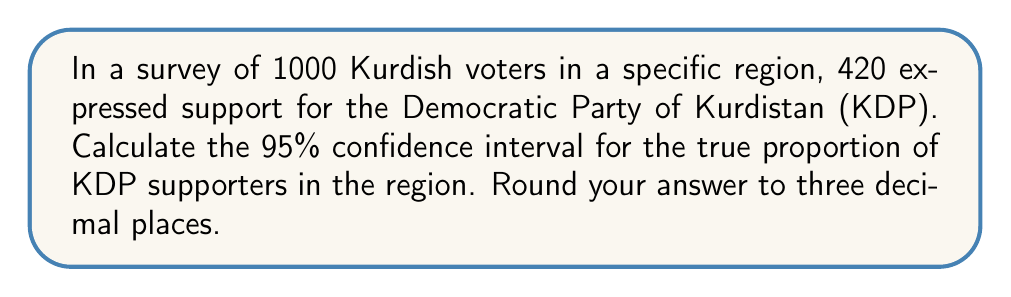Can you solve this math problem? To calculate the confidence interval, we'll use the formula for the margin of error in a proportion:

1. Calculate the sample proportion:
   $\hat{p} = \frac{420}{1000} = 0.42$

2. Calculate the standard error:
   $SE = \sqrt{\frac{\hat{p}(1-\hat{p})}{n}} = \sqrt{\frac{0.42(1-0.42)}{1000}} = 0.0156$

3. For a 95% confidence interval, we use a z-score of 1.96.

4. Calculate the margin of error:
   $ME = 1.96 \times SE = 1.96 \times 0.0156 = 0.0306$

5. Calculate the confidence interval:
   Lower bound: $0.42 - 0.0306 = 0.3894$
   Upper bound: $0.42 + 0.0306 = 0.4506$

6. Round to three decimal places:
   $$(0.389, 0.451)$$

This means we can be 95% confident that the true proportion of KDP supporters in the region is between 38.9% and 45.1%.
Answer: (0.389, 0.451) 